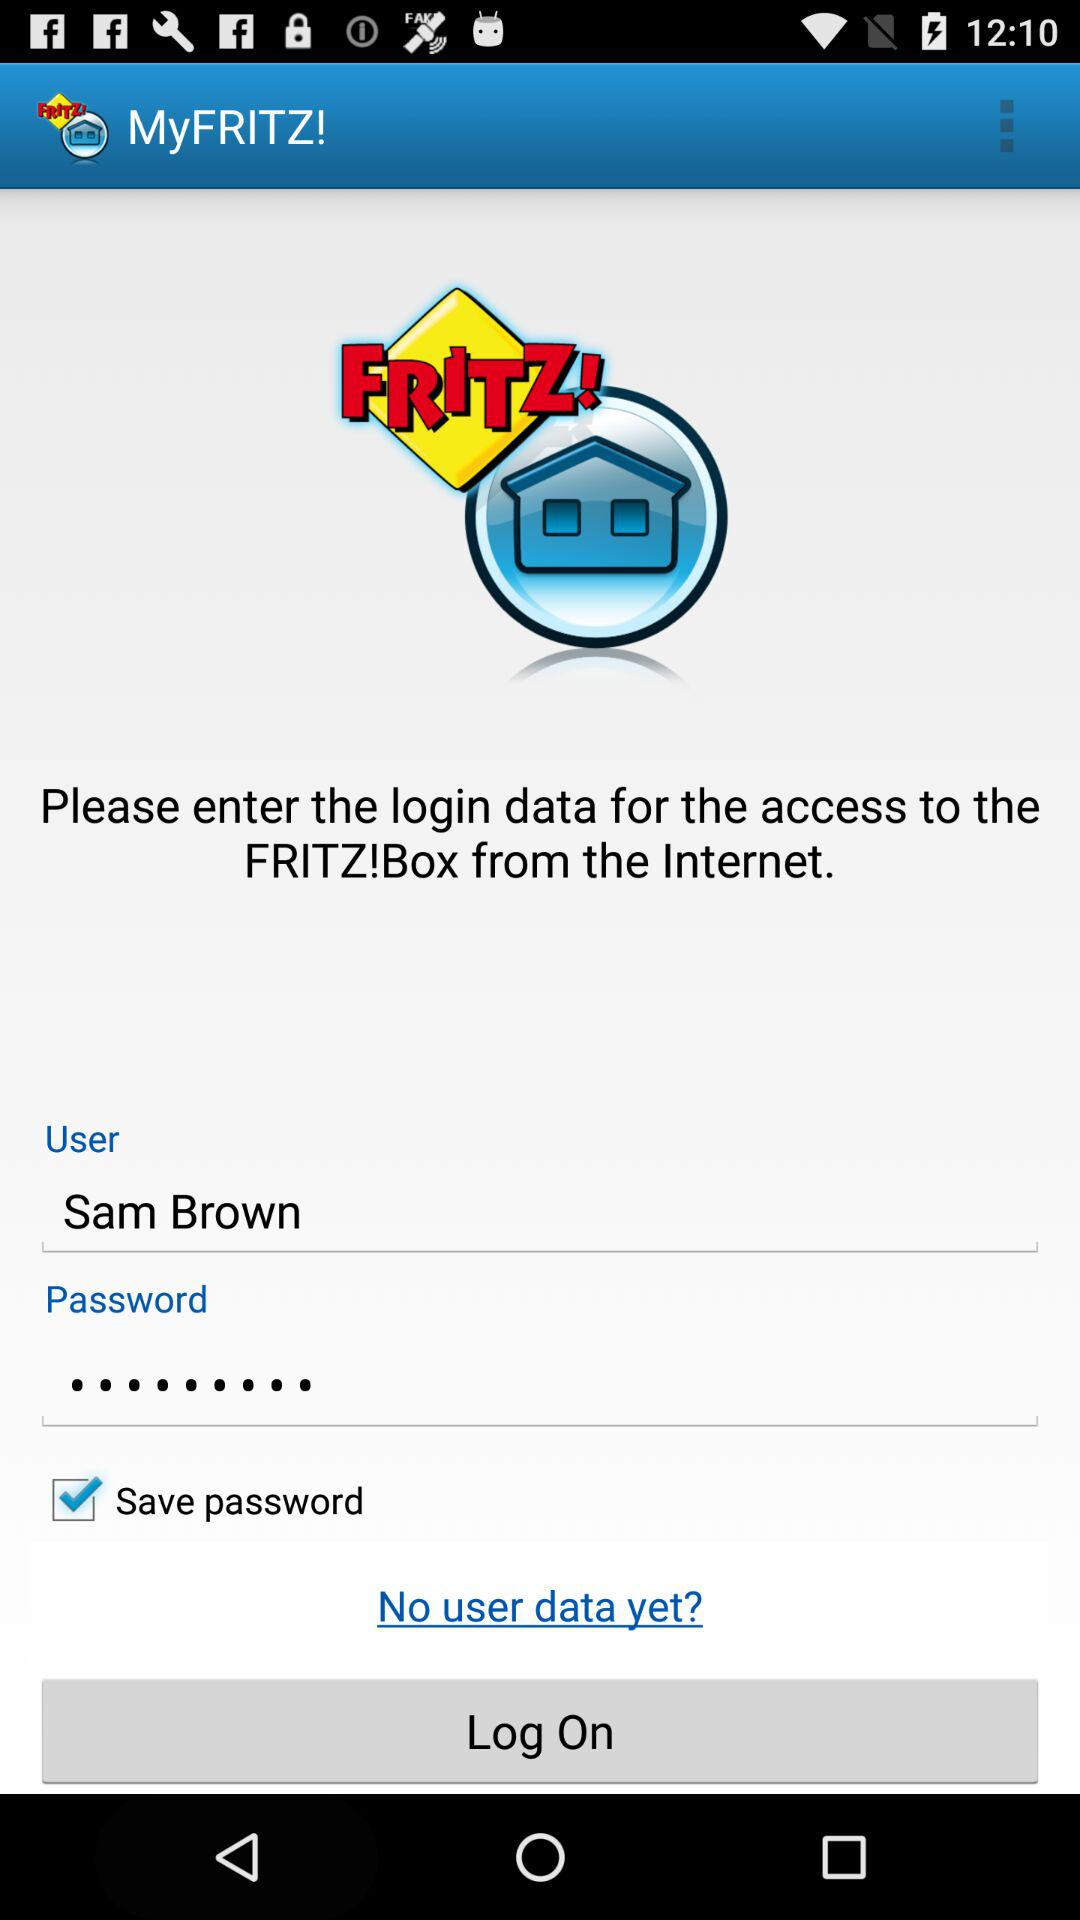What is the app name? The app name is "MyFRITZ!". 